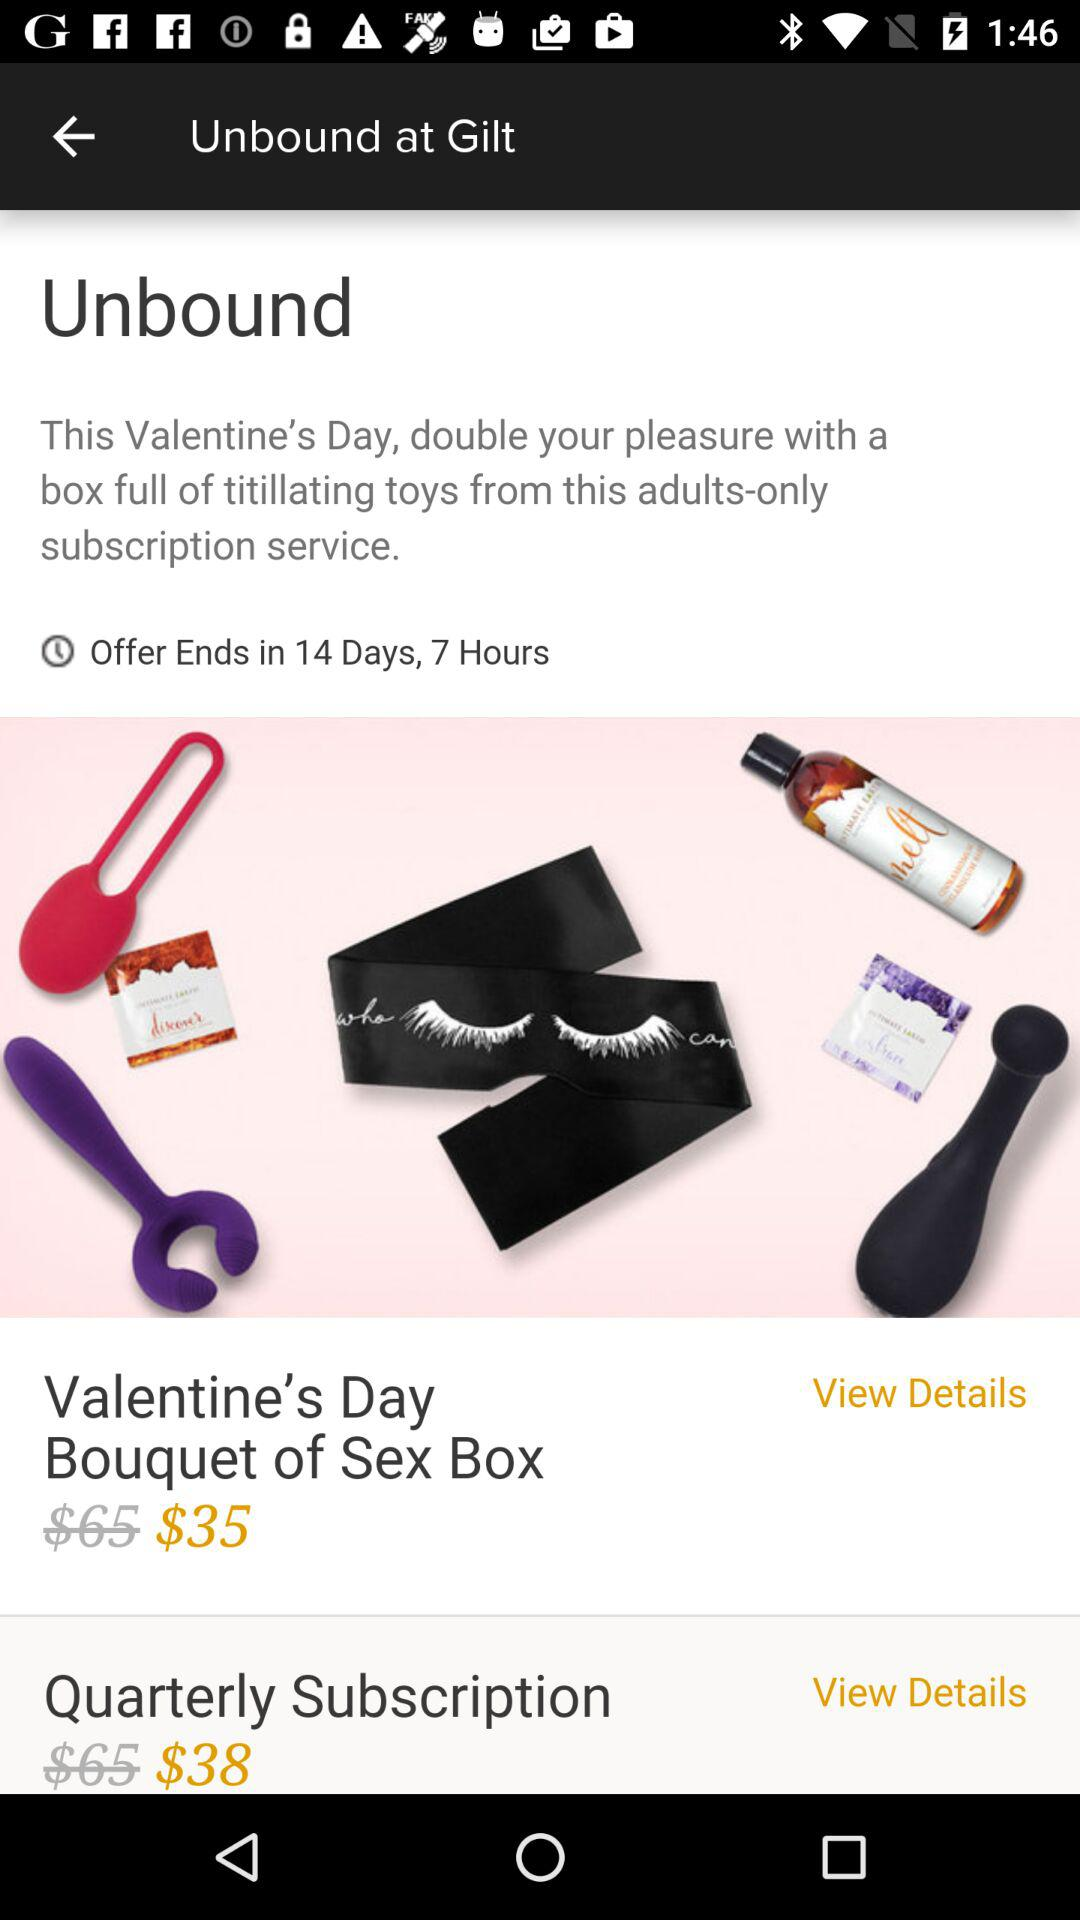What's the discounted price of the quarterly subscription? The discounted price is $38. 